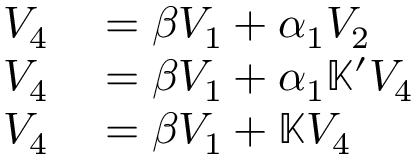Convert formula to latex. <formula><loc_0><loc_0><loc_500><loc_500>\begin{array} { r l } { V _ { 4 } } & = \beta V _ { 1 } + \alpha _ { 1 } V _ { 2 } } \\ { V _ { 4 } } & = \beta V _ { 1 } + \alpha _ { 1 } \mathbb { K } ^ { \prime } V _ { 4 } } \\ { V _ { 4 } } & = \beta V _ { 1 } + \mathbb { K } V _ { 4 } } \end{array}</formula> 